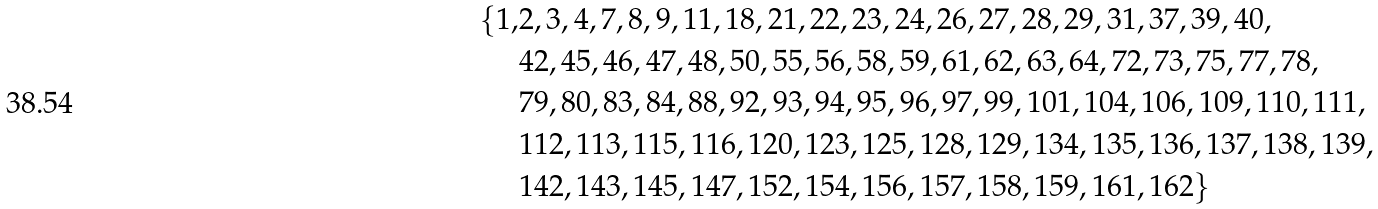Convert formula to latex. <formula><loc_0><loc_0><loc_500><loc_500>\{ 1 , & 2 , 3 , 4 , 7 , 8 , 9 , 1 1 , 1 8 , 2 1 , 2 2 , 2 3 , 2 4 , 2 6 , 2 7 , 2 8 , 2 9 , 3 1 , 3 7 , 3 9 , 4 0 , \\ & 4 2 , 4 5 , 4 6 , 4 7 , 4 8 , 5 0 , 5 5 , 5 6 , 5 8 , 5 9 , 6 1 , 6 2 , 6 3 , 6 4 , 7 2 , 7 3 , 7 5 , 7 7 , 7 8 , \\ & 7 9 , 8 0 , 8 3 , 8 4 , 8 8 , 9 2 , 9 3 , 9 4 , 9 5 , 9 6 , 9 7 , 9 9 , 1 0 1 , 1 0 4 , 1 0 6 , 1 0 9 , 1 1 0 , 1 1 1 , \\ & 1 1 2 , 1 1 3 , 1 1 5 , 1 1 6 , 1 2 0 , 1 2 3 , 1 2 5 , 1 2 8 , 1 2 9 , 1 3 4 , 1 3 5 , 1 3 6 , 1 3 7 , 1 3 8 , 1 3 9 , \\ & 1 4 2 , 1 4 3 , 1 4 5 , 1 4 7 , 1 5 2 , 1 5 4 , 1 5 6 , 1 5 7 , 1 5 8 , 1 5 9 , 1 6 1 , 1 6 2 \}</formula> 